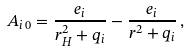<formula> <loc_0><loc_0><loc_500><loc_500>A _ { i \, 0 } = \frac { e _ { i } } { r _ { H } ^ { 2 } + q _ { i } } - \frac { e _ { i } } { r ^ { 2 } + q _ { i } } \, ,</formula> 